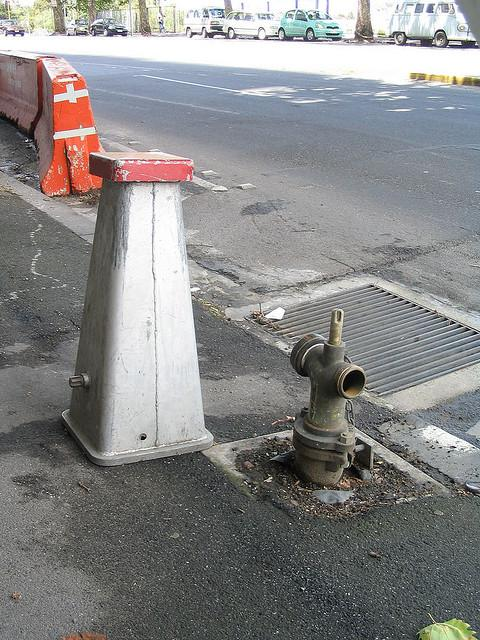What is on the floor?

Choices:
A) cow
B) grate
C) egg sandwich
D) pizza grate 